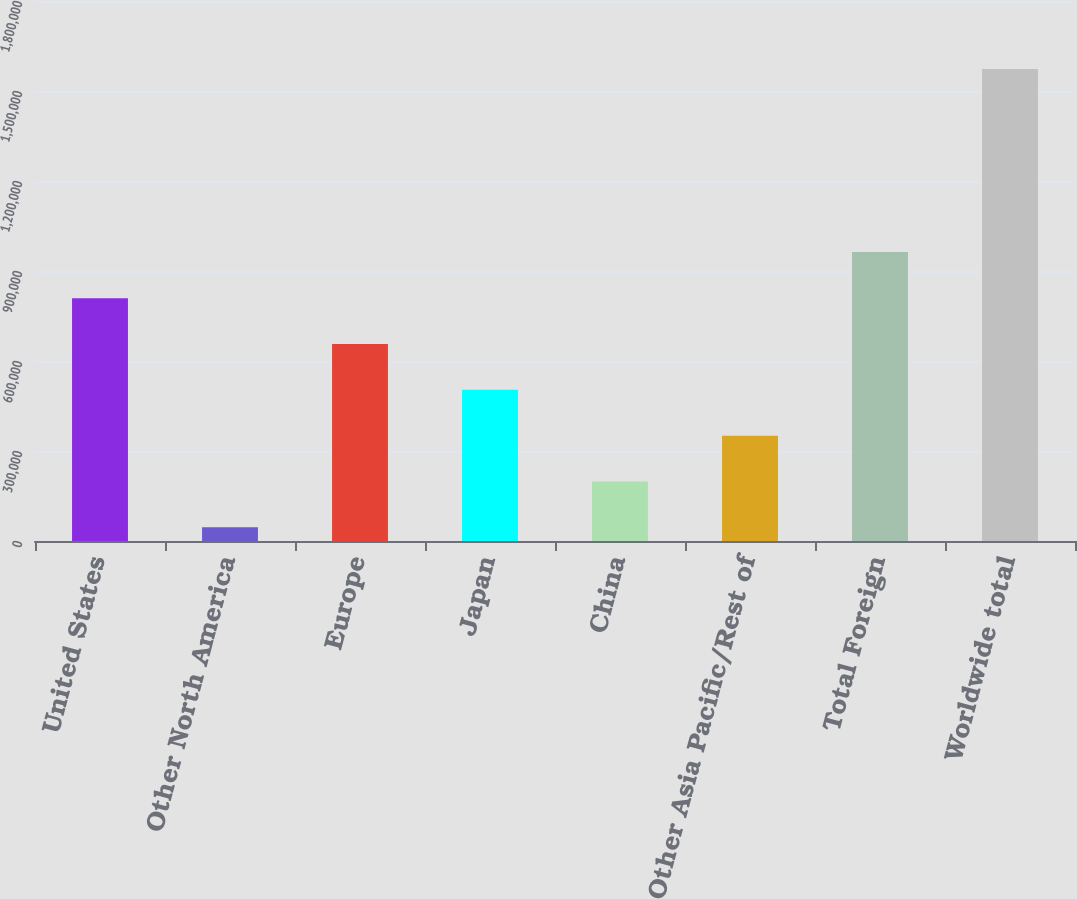<chart> <loc_0><loc_0><loc_500><loc_500><bar_chart><fcel>United States<fcel>Other North America<fcel>Europe<fcel>Japan<fcel>China<fcel>Other Asia Pacific/Rest of<fcel>Total Foreign<fcel>Worldwide total<nl><fcel>809369<fcel>45505<fcel>656596<fcel>503823<fcel>198278<fcel>351051<fcel>963629<fcel>1.57323e+06<nl></chart> 